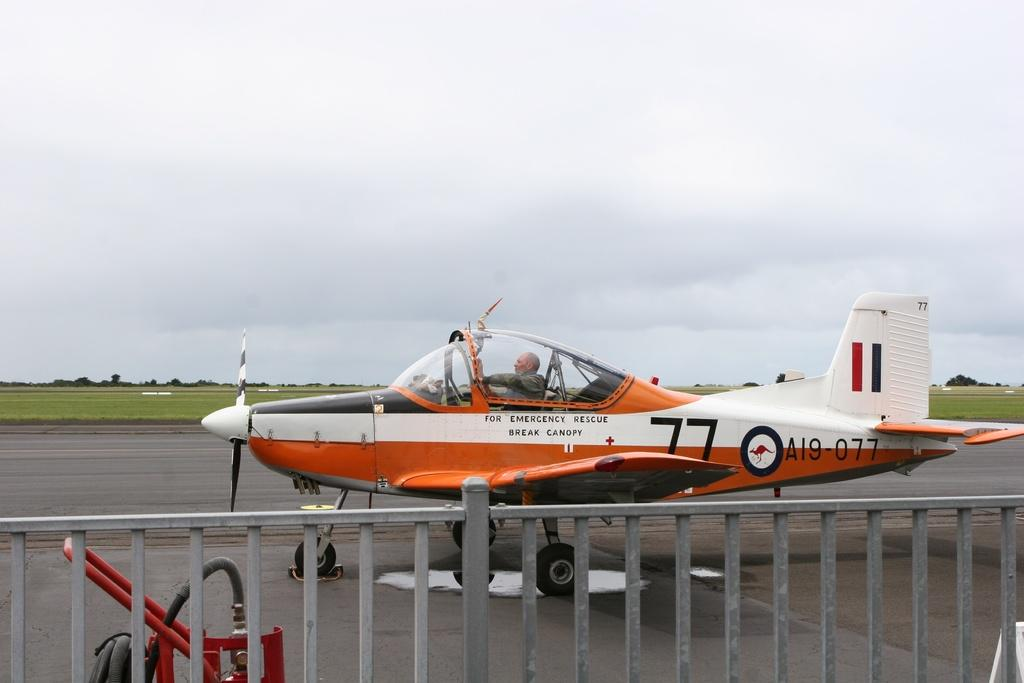<image>
Relay a brief, clear account of the picture shown. For emergency rescue situations on this plane the instructions say to break canopy. 